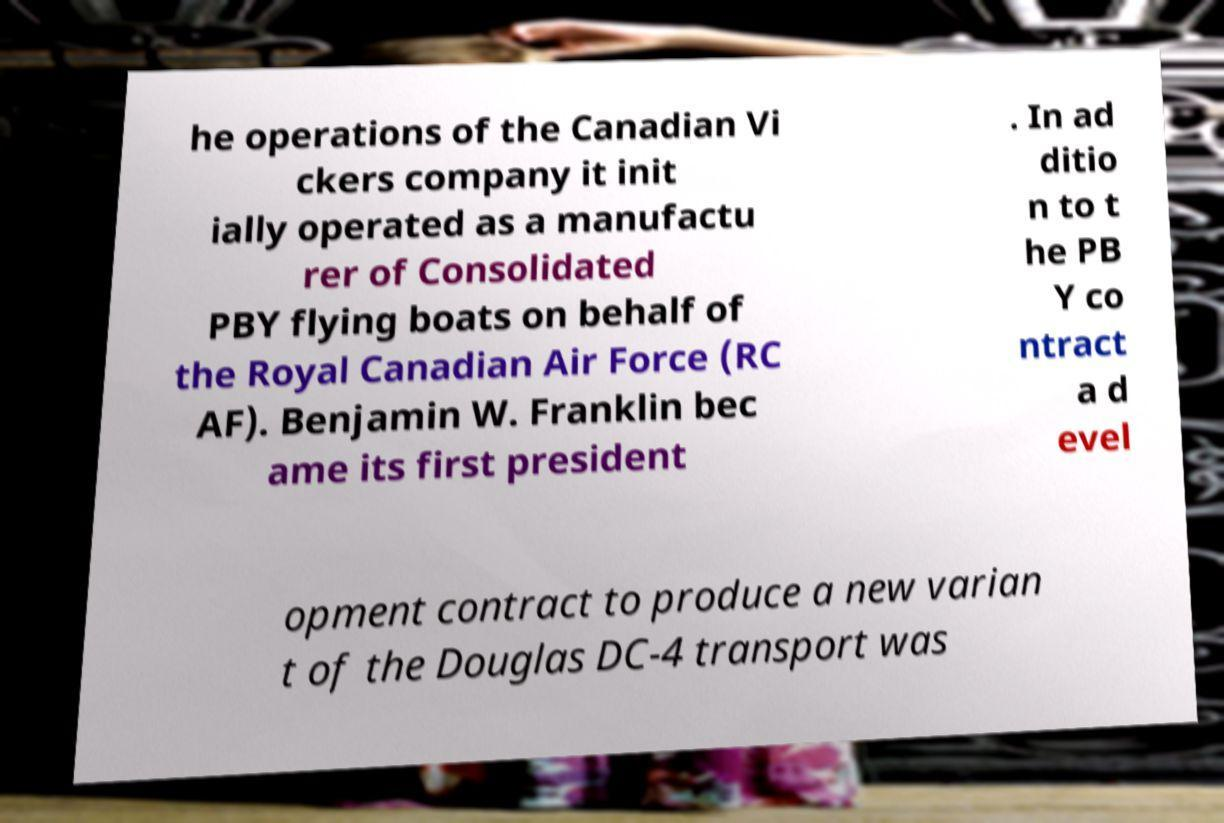For documentation purposes, I need the text within this image transcribed. Could you provide that? he operations of the Canadian Vi ckers company it init ially operated as a manufactu rer of Consolidated PBY flying boats on behalf of the Royal Canadian Air Force (RC AF). Benjamin W. Franklin bec ame its first president . In ad ditio n to t he PB Y co ntract a d evel opment contract to produce a new varian t of the Douglas DC-4 transport was 